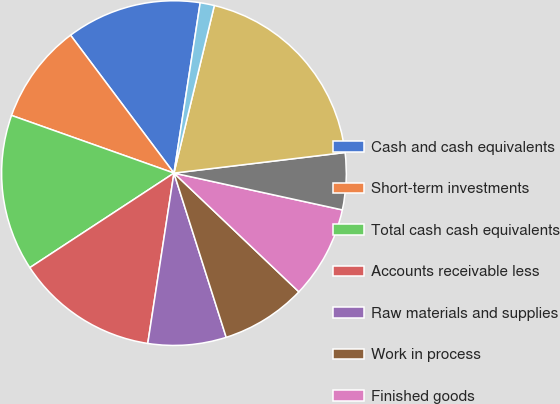Convert chart. <chart><loc_0><loc_0><loc_500><loc_500><pie_chart><fcel>Cash and cash equivalents<fcel>Short-term investments<fcel>Total cash cash equivalents<fcel>Accounts receivable less<fcel>Raw materials and supplies<fcel>Work in process<fcel>Finished goods<fcel>Other current assets<fcel>Total current assets<fcel>Land<nl><fcel>12.67%<fcel>9.33%<fcel>14.67%<fcel>13.33%<fcel>7.33%<fcel>8.0%<fcel>8.67%<fcel>5.33%<fcel>19.33%<fcel>1.33%<nl></chart> 